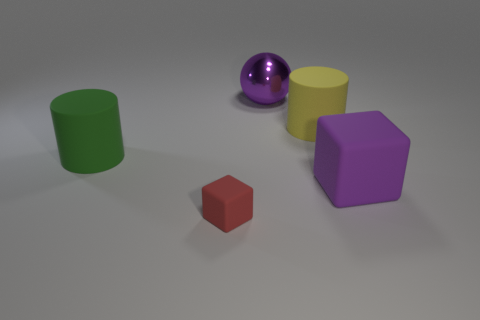There is a purple thing in front of the green object; does it have the same size as the rubber cylinder that is left of the large sphere?
Your response must be concise. Yes. Is the number of metallic spheres in front of the red matte block greater than the number of small things left of the green cylinder?
Keep it short and to the point. No. How many other matte things have the same shape as the large green thing?
Your response must be concise. 1. There is a green cylinder that is the same size as the purple block; what is its material?
Your answer should be very brief. Rubber. Are there any green cylinders made of the same material as the tiny red cube?
Offer a very short reply. Yes. Are there fewer big cylinders behind the tiny block than rubber things?
Give a very brief answer. Yes. There is a large purple object behind the big purple object right of the large purple metal object; what is it made of?
Offer a very short reply. Metal. What is the shape of the thing that is both on the left side of the purple metallic sphere and in front of the large green rubber cylinder?
Your response must be concise. Cube. How many other things are the same color as the large cube?
Provide a short and direct response. 1. How many objects are large matte objects that are on the right side of the green object or small purple spheres?
Provide a short and direct response. 2. 